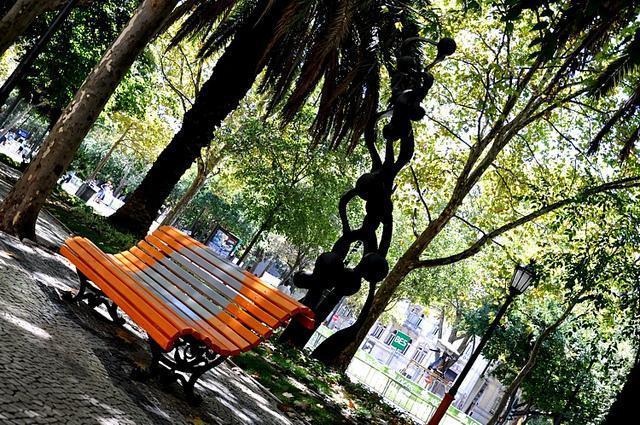How many benches are in the photo?
Give a very brief answer. 1. How many birds have red on their head?
Give a very brief answer. 0. 